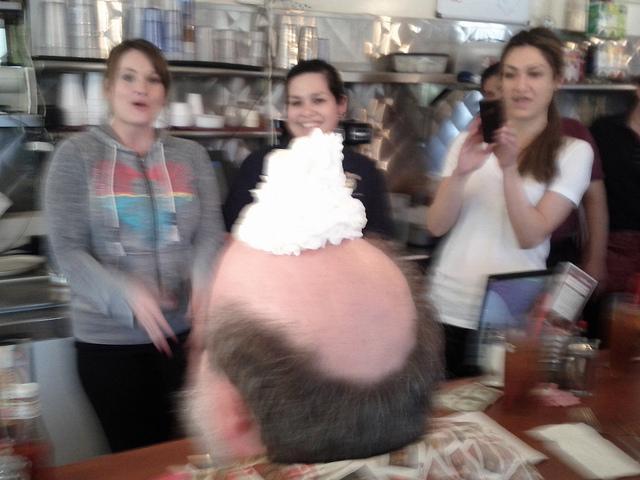What does the woman do with her phone?
From the following set of four choices, select the accurate answer to respond to the question.
Options: Take photo, call, text, auto dial. Take photo. 